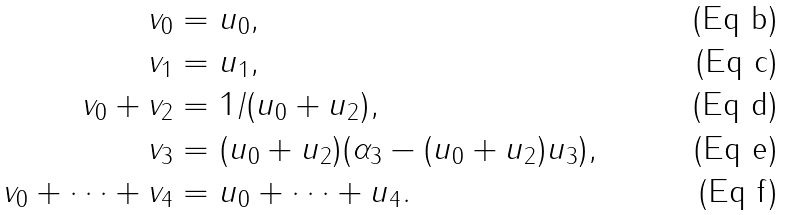<formula> <loc_0><loc_0><loc_500><loc_500>v _ { 0 } & = u _ { 0 } , \\ v _ { 1 } & = u _ { 1 } , \\ v _ { 0 } + v _ { 2 } & = 1 / ( u _ { 0 } + u _ { 2 } ) , \\ v _ { 3 } & = ( u _ { 0 } + u _ { 2 } ) ( \alpha _ { 3 } - ( u _ { 0 } + u _ { 2 } ) u _ { 3 } ) , \\ v _ { 0 } + \cdots + v _ { 4 } & = u _ { 0 } + \cdots + u _ { 4 } .</formula> 